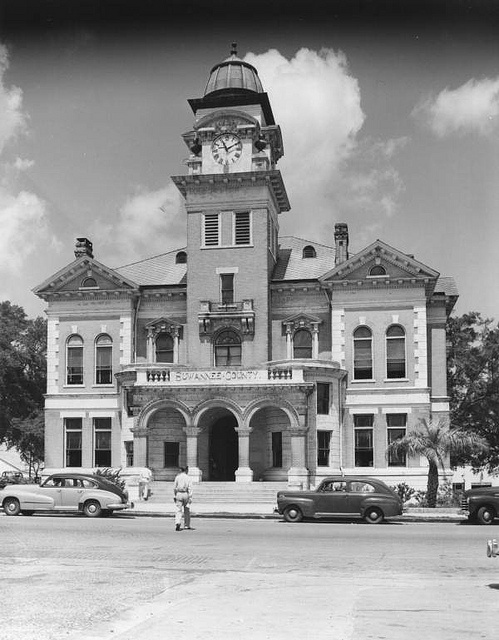Describe the objects in this image and their specific colors. I can see car in black, gray, darkgray, and lightgray tones, car in black, darkgray, lightgray, and gray tones, car in black, gray, darkgray, and lightgray tones, people in black, lightgray, gray, and darkgray tones, and clock in black, lightgray, darkgray, and gray tones in this image. 